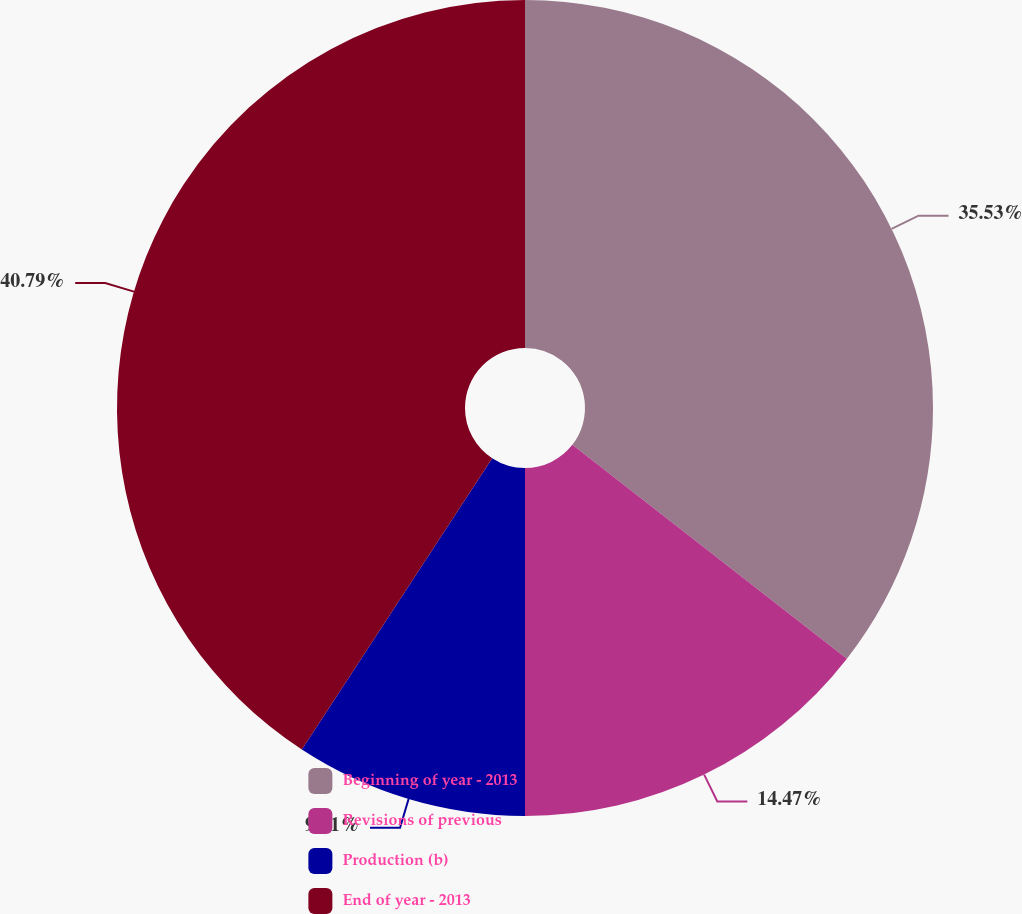Convert chart. <chart><loc_0><loc_0><loc_500><loc_500><pie_chart><fcel>Beginning of year - 2013<fcel>Revisions of previous<fcel>Production (b)<fcel>End of year - 2013<nl><fcel>35.53%<fcel>14.47%<fcel>9.21%<fcel>40.79%<nl></chart> 